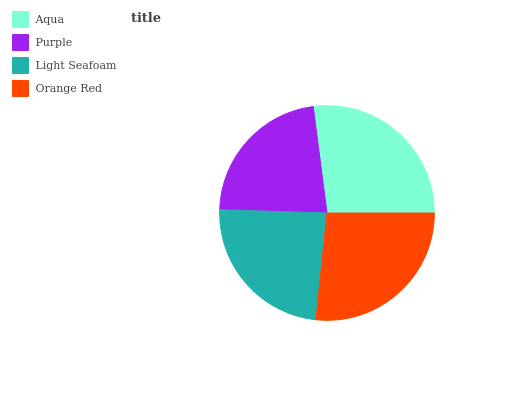Is Purple the minimum?
Answer yes or no. Yes. Is Aqua the maximum?
Answer yes or no. Yes. Is Light Seafoam the minimum?
Answer yes or no. No. Is Light Seafoam the maximum?
Answer yes or no. No. Is Light Seafoam greater than Purple?
Answer yes or no. Yes. Is Purple less than Light Seafoam?
Answer yes or no. Yes. Is Purple greater than Light Seafoam?
Answer yes or no. No. Is Light Seafoam less than Purple?
Answer yes or no. No. Is Orange Red the high median?
Answer yes or no. Yes. Is Light Seafoam the low median?
Answer yes or no. Yes. Is Aqua the high median?
Answer yes or no. No. Is Aqua the low median?
Answer yes or no. No. 